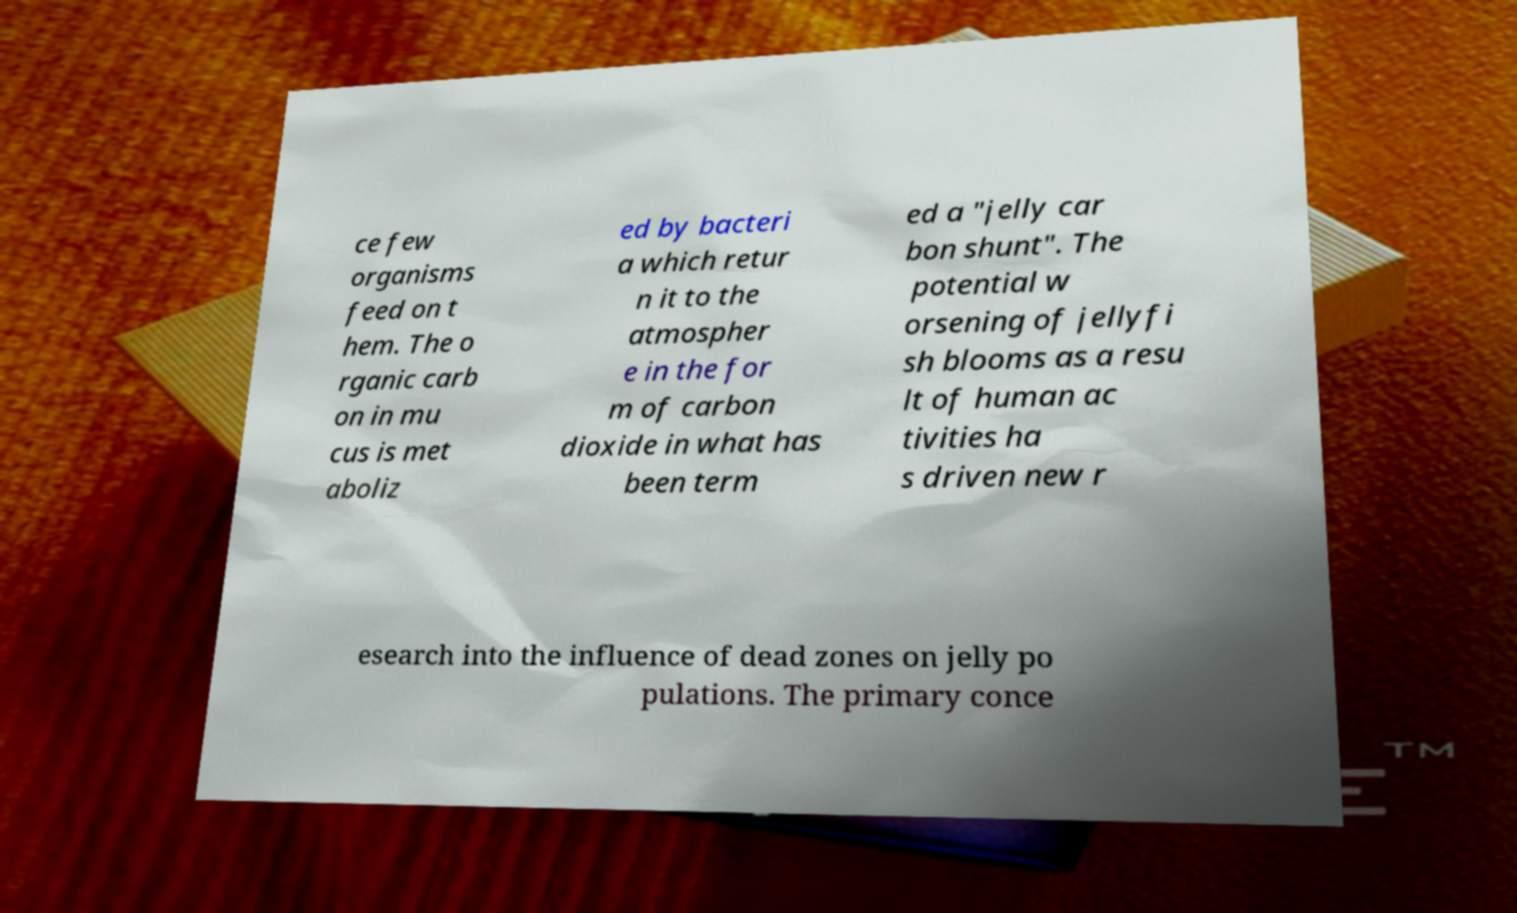Can you accurately transcribe the text from the provided image for me? ce few organisms feed on t hem. The o rganic carb on in mu cus is met aboliz ed by bacteri a which retur n it to the atmospher e in the for m of carbon dioxide in what has been term ed a "jelly car bon shunt". The potential w orsening of jellyfi sh blooms as a resu lt of human ac tivities ha s driven new r esearch into the influence of dead zones on jelly po pulations. The primary conce 